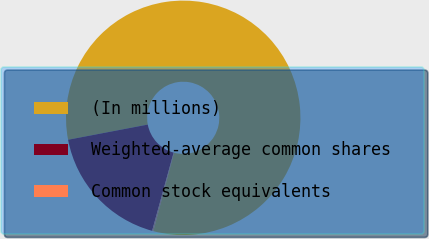<chart> <loc_0><loc_0><loc_500><loc_500><pie_chart><fcel>(In millions)<fcel>Weighted-average common shares<fcel>Common stock equivalents<nl><fcel>82.11%<fcel>17.73%<fcel>0.17%<nl></chart> 